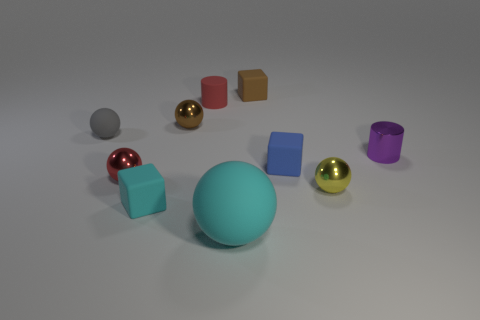There is a tiny rubber cylinder; is it the same color as the matte sphere behind the metallic cylinder?
Your answer should be very brief. No. What is the shape of the tiny object that is the same color as the large rubber thing?
Ensure brevity in your answer.  Cube. There is a tiny red metallic thing; what shape is it?
Your response must be concise. Sphere. Is the color of the large matte ball the same as the metal cylinder?
Offer a very short reply. No. What number of things are things in front of the tiny cyan block or small matte cylinders?
Provide a succinct answer. 2. There is a gray object that is the same material as the small cyan block; what size is it?
Make the answer very short. Small. Is the number of brown matte things that are left of the tiny cyan thing greater than the number of small purple metallic things?
Your answer should be compact. No. Is the shape of the tiny gray object the same as the brown thing that is in front of the small red rubber object?
Give a very brief answer. Yes. What number of tiny objects are either cyan spheres or red things?
Offer a very short reply. 2. What size is the rubber cube that is the same color as the large sphere?
Make the answer very short. Small. 